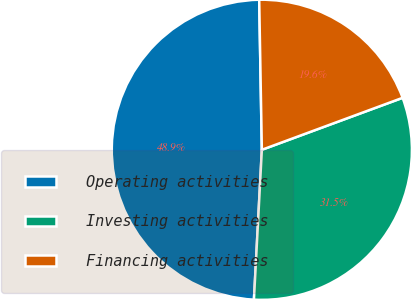<chart> <loc_0><loc_0><loc_500><loc_500><pie_chart><fcel>Operating activities<fcel>Investing activities<fcel>Financing activities<nl><fcel>48.88%<fcel>31.47%<fcel>19.65%<nl></chart> 